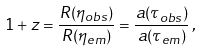Convert formula to latex. <formula><loc_0><loc_0><loc_500><loc_500>1 + z = \frac { R ( \eta _ { o b s } ) } { R ( \eta _ { e m } ) } = \frac { a ( \tau _ { o b s } ) } { a ( \tau _ { e m } ) } \, ,</formula> 